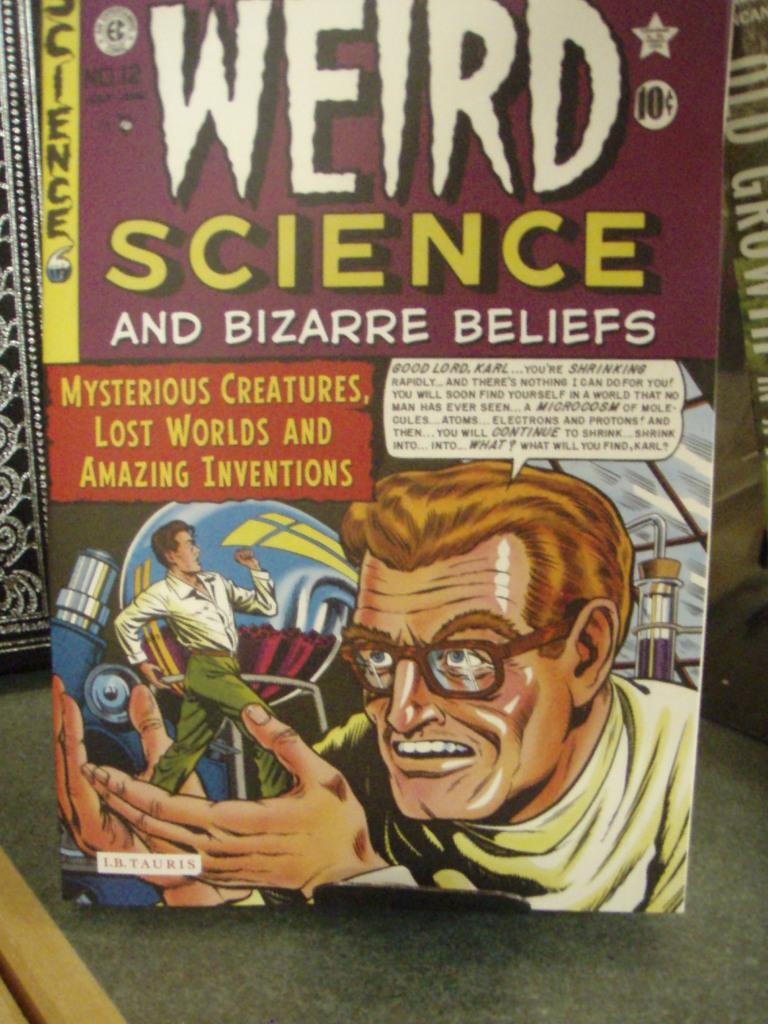Provide a one-sentence caption for the provided image. A mad scientist adorns the cover of a Weird Science comic book. 